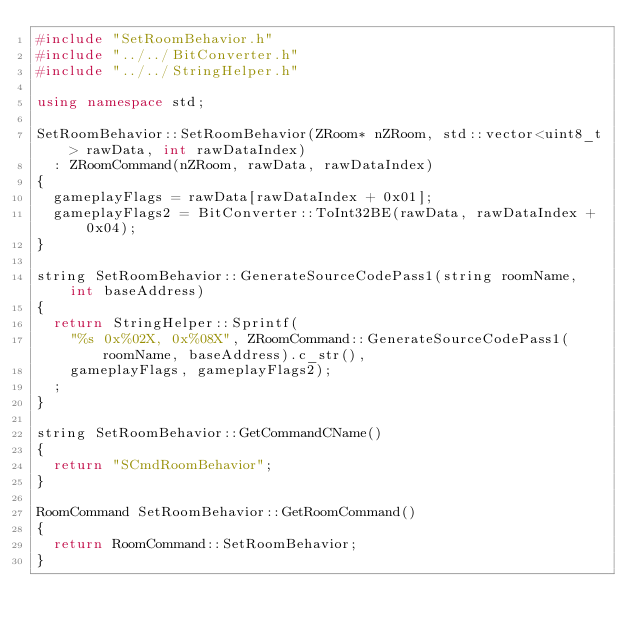Convert code to text. <code><loc_0><loc_0><loc_500><loc_500><_C++_>#include "SetRoomBehavior.h"
#include "../../BitConverter.h"
#include "../../StringHelper.h"

using namespace std;

SetRoomBehavior::SetRoomBehavior(ZRoom* nZRoom, std::vector<uint8_t> rawData, int rawDataIndex)
	: ZRoomCommand(nZRoom, rawData, rawDataIndex)
{
	gameplayFlags = rawData[rawDataIndex + 0x01];
	gameplayFlags2 = BitConverter::ToInt32BE(rawData, rawDataIndex + 0x04);
}

string SetRoomBehavior::GenerateSourceCodePass1(string roomName, int baseAddress)
{
	return StringHelper::Sprintf(
		"%s 0x%02X, 0x%08X", ZRoomCommand::GenerateSourceCodePass1(roomName, baseAddress).c_str(),
		gameplayFlags, gameplayFlags2);
	;
}

string SetRoomBehavior::GetCommandCName()
{
	return "SCmdRoomBehavior";
}

RoomCommand SetRoomBehavior::GetRoomCommand()
{
	return RoomCommand::SetRoomBehavior;
}</code> 